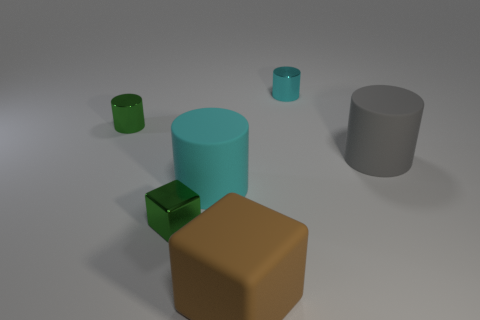There is another cylinder that is the same size as the gray cylinder; what is its color?
Provide a short and direct response. Cyan. Are there any tiny green cubes in front of the tiny cylinder behind the green cylinder?
Give a very brief answer. Yes. How many cubes are large brown things or cyan objects?
Give a very brief answer. 1. What size is the thing behind the tiny green object that is behind the large object that is on the right side of the cyan shiny object?
Your answer should be compact. Small. Are there any large brown blocks behind the small green metal block?
Your answer should be compact. No. There is a thing that is the same color as the small block; what is its shape?
Keep it short and to the point. Cylinder. What number of things are things that are to the right of the rubber cube or tiny yellow shiny things?
Provide a short and direct response. 2. What size is the cyan cylinder that is made of the same material as the brown cube?
Provide a short and direct response. Large. Is the size of the gray rubber cylinder the same as the thing that is behind the green cylinder?
Ensure brevity in your answer.  No. The cylinder that is behind the large cyan thing and left of the brown rubber block is what color?
Keep it short and to the point. Green. 